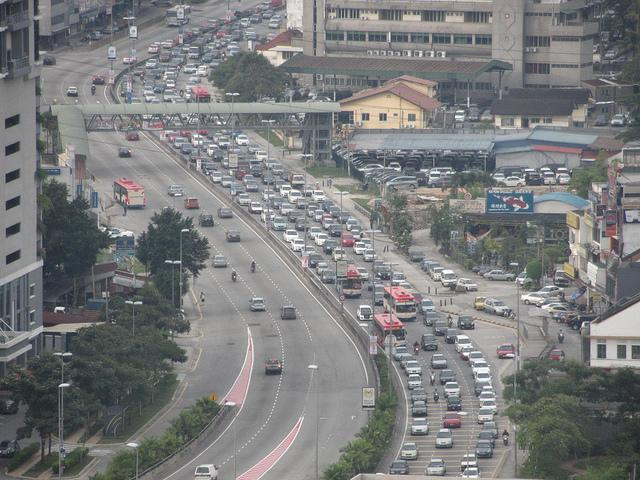What time is it likely to be? Please explain your reasoning. 845 am. This is rush hour traffic as people try to get to work 